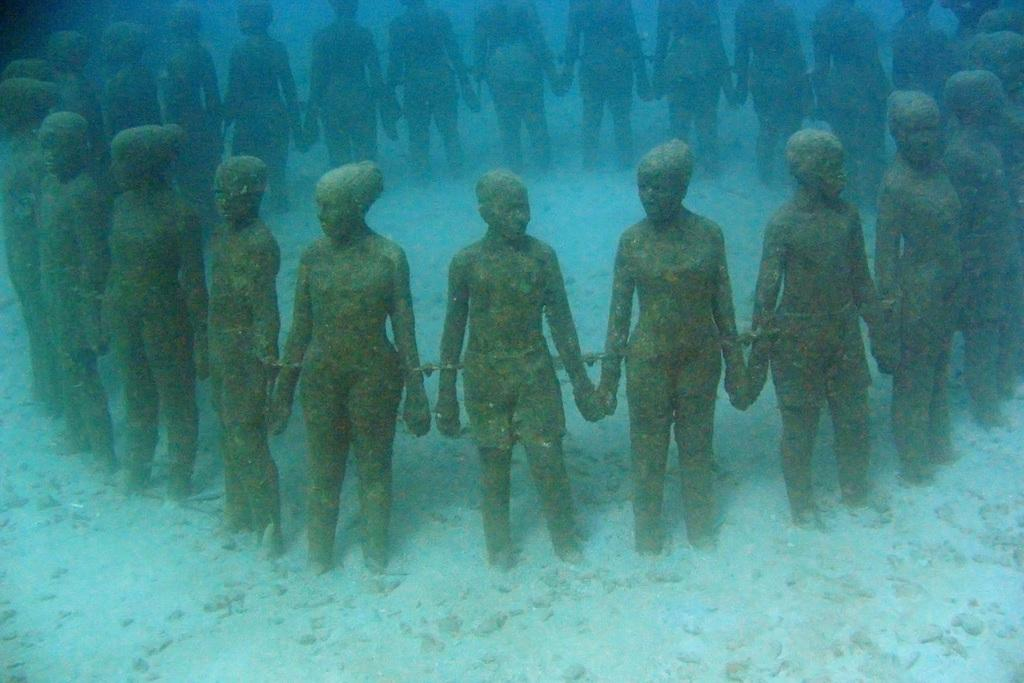Where was the image taken? The image was taken inside the water. What can be seen in the image besides the water? There are statues of persons in the image. What type of scent can be detected in the image? There is no mention of a scent in the image, as it focuses on statues of persons inside the water. 